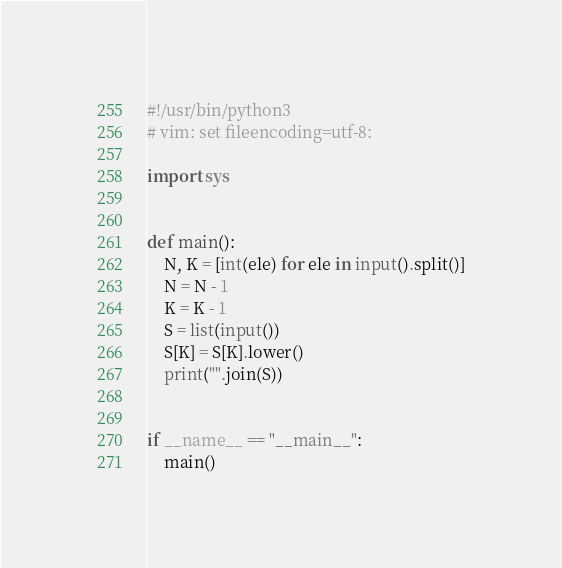Convert code to text. <code><loc_0><loc_0><loc_500><loc_500><_Python_>#!/usr/bin/python3
# vim: set fileencoding=utf-8:

import sys


def main():
    N, K = [int(ele) for ele in input().split()]
    N = N - 1
    K = K - 1
    S = list(input())
    S[K] = S[K].lower()
    print("".join(S))


if __name__ == "__main__":
    main()
</code> 